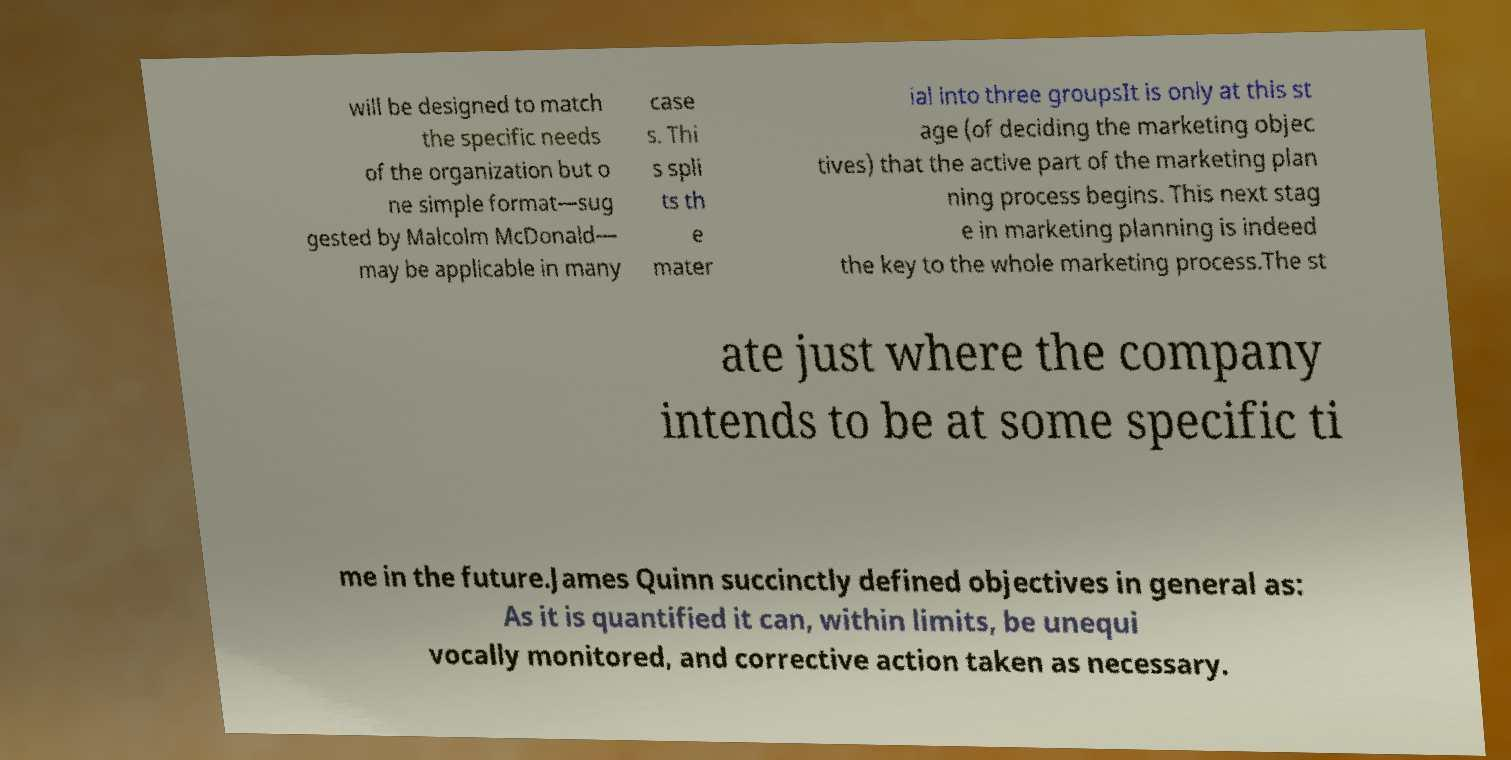I need the written content from this picture converted into text. Can you do that? will be designed to match the specific needs of the organization but o ne simple format—sug gested by Malcolm McDonald— may be applicable in many case s. Thi s spli ts th e mater ial into three groupsIt is only at this st age (of deciding the marketing objec tives) that the active part of the marketing plan ning process begins. This next stag e in marketing planning is indeed the key to the whole marketing process.The st ate just where the company intends to be at some specific ti me in the future.James Quinn succinctly defined objectives in general as: As it is quantified it can, within limits, be unequi vocally monitored, and corrective action taken as necessary. 